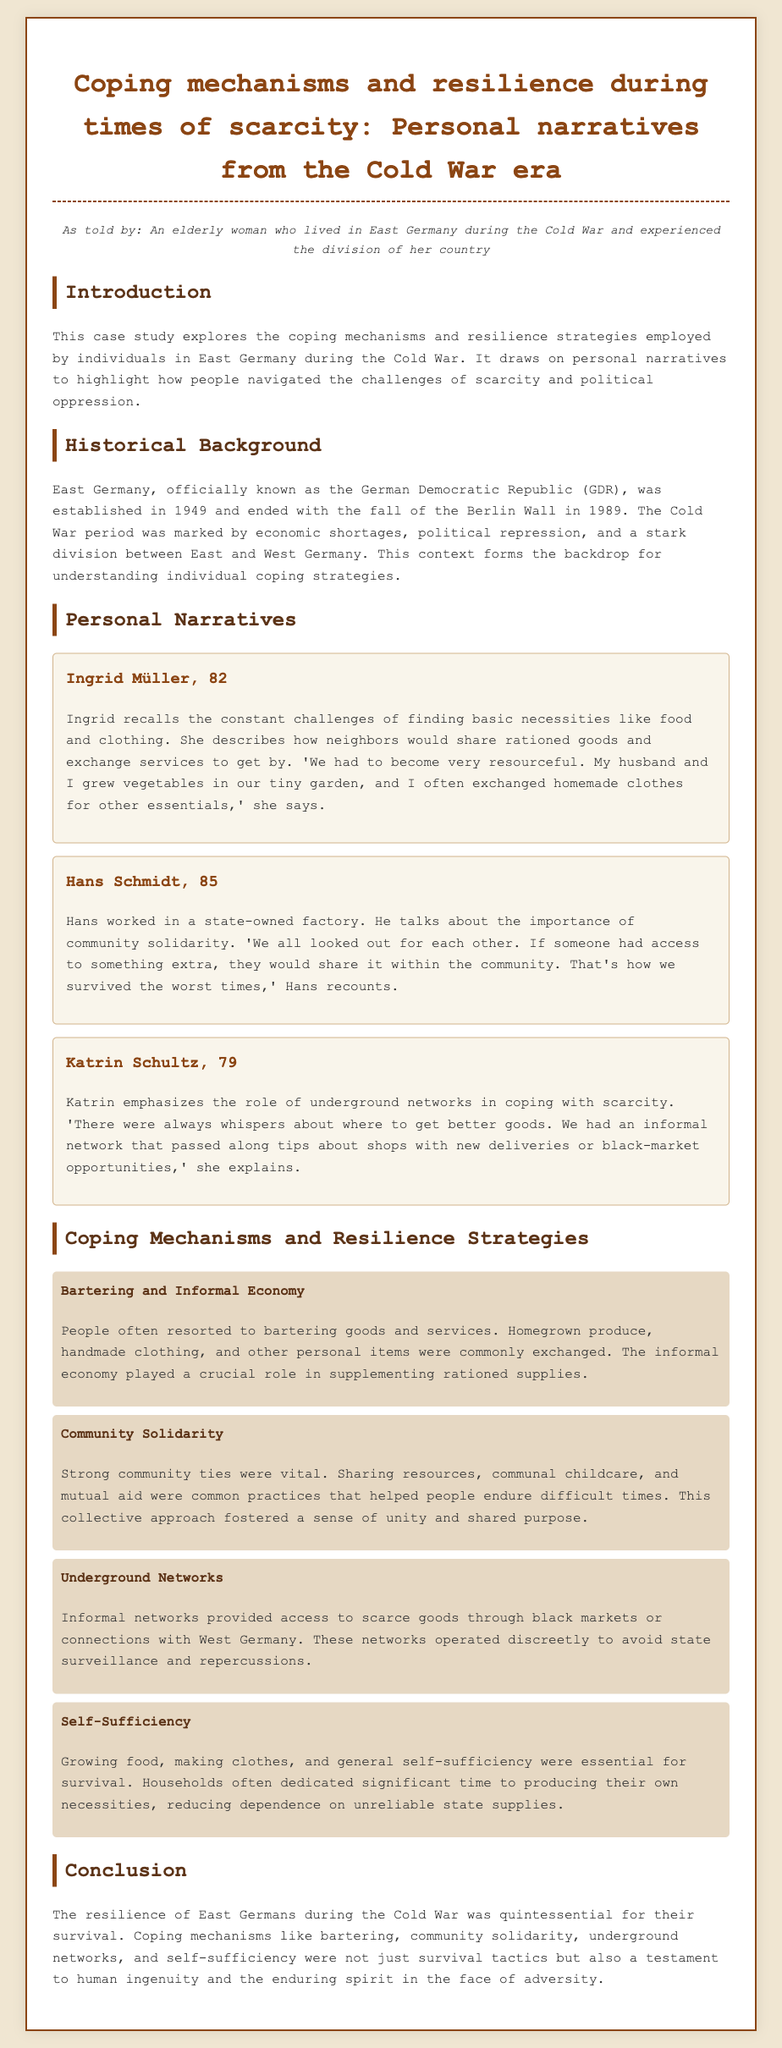what is the title of the case study? The title is given in the header and describes the focus of the study on personal narratives regarding coping mechanisms and resilience during the Cold War era.
Answer: Coping mechanisms and resilience during times of scarcity: Personal narratives from the Cold War era who is the first person narrating their experience? The first person mentioned in the personal narratives section is named, and their age is also provided.
Answer: Ingrid Müller, 82 what coping mechanism involved exchanging goods and services? This mechanism is described in the section discussing how individuals navigated scarcity through informal practices.
Answer: Bartering and Informal Economy which strategy emphasizes relying on community support? This strategy highlights the importance of a unified approach among neighbors during challenging times.
Answer: Community Solidarity what does Katrin Schultz mention about informal networks? Katrin discusses an important aspect of how people coped with scarcity by relying on certain networks for information.
Answer: Underground Networks how many personal narratives are included in the document? The document specifies the number of personal stories shared by different individuals reflecting on their experiences.
Answer: Three what was the primary method of growing food mentioned in the narratives? This method is highlighted as a form of self-sufficiency crucial for survival.
Answer: Growing vegetables when did East Germany cease to exist? The study provides a historical context that mentions the year marking the end of East Germany as a separate entity.
Answer: 1989 